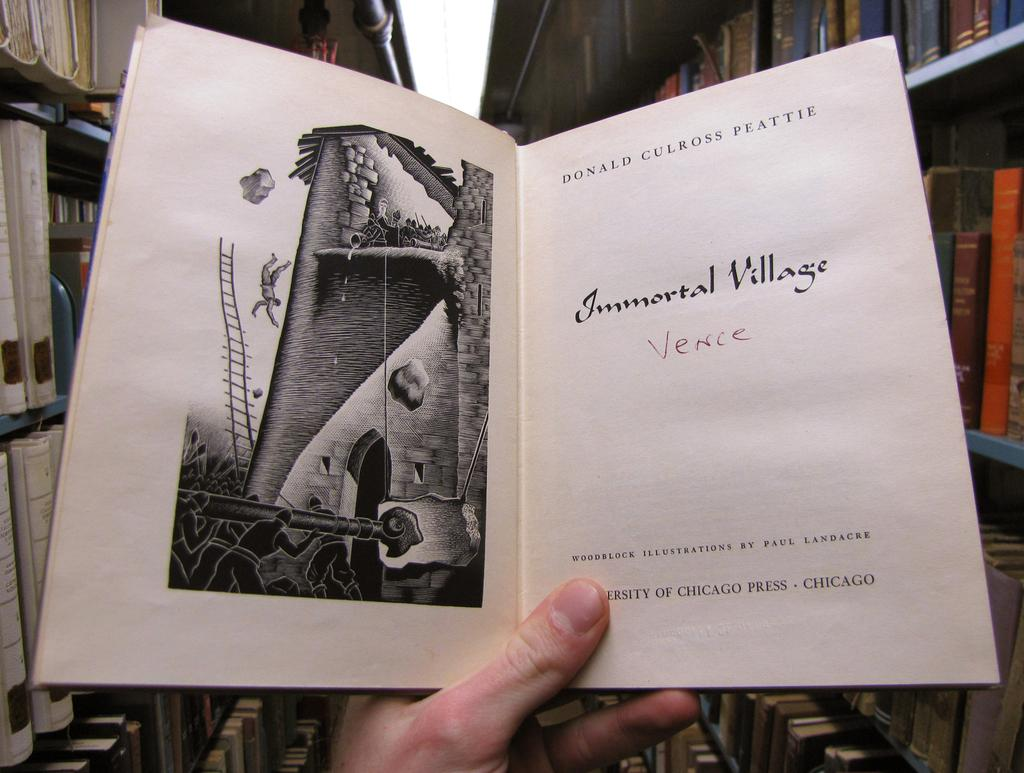Provide a one-sentence caption for the provided image. A person holding a book titled Immortal Village: Venice and written by Donald Culross Peattie. 